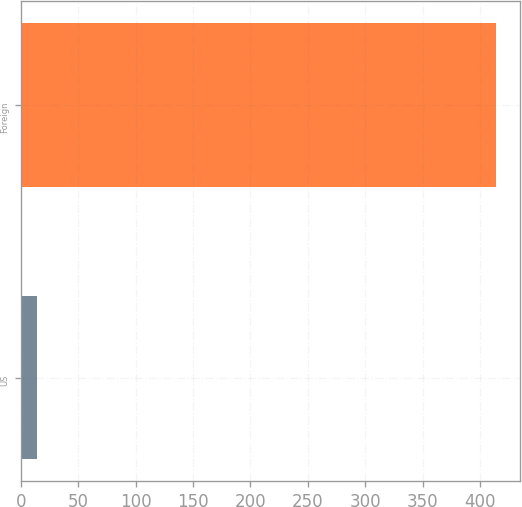<chart> <loc_0><loc_0><loc_500><loc_500><bar_chart><fcel>US<fcel>Foreign<nl><fcel>14<fcel>414<nl></chart> 